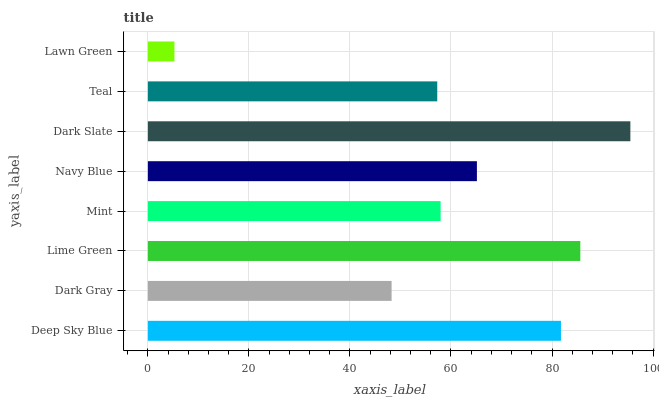Is Lawn Green the minimum?
Answer yes or no. Yes. Is Dark Slate the maximum?
Answer yes or no. Yes. Is Dark Gray the minimum?
Answer yes or no. No. Is Dark Gray the maximum?
Answer yes or no. No. Is Deep Sky Blue greater than Dark Gray?
Answer yes or no. Yes. Is Dark Gray less than Deep Sky Blue?
Answer yes or no. Yes. Is Dark Gray greater than Deep Sky Blue?
Answer yes or no. No. Is Deep Sky Blue less than Dark Gray?
Answer yes or no. No. Is Navy Blue the high median?
Answer yes or no. Yes. Is Mint the low median?
Answer yes or no. Yes. Is Lime Green the high median?
Answer yes or no. No. Is Lawn Green the low median?
Answer yes or no. No. 